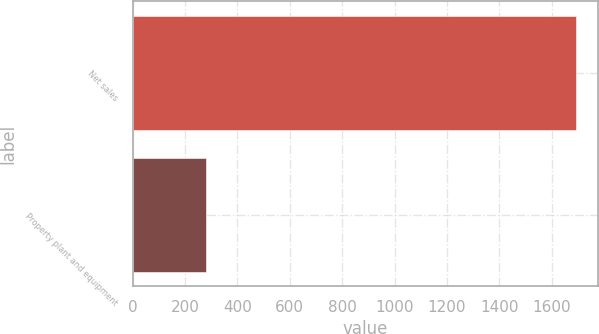<chart> <loc_0><loc_0><loc_500><loc_500><bar_chart><fcel>Net sales<fcel>Property plant and equipment<nl><fcel>1692.1<fcel>280.7<nl></chart> 